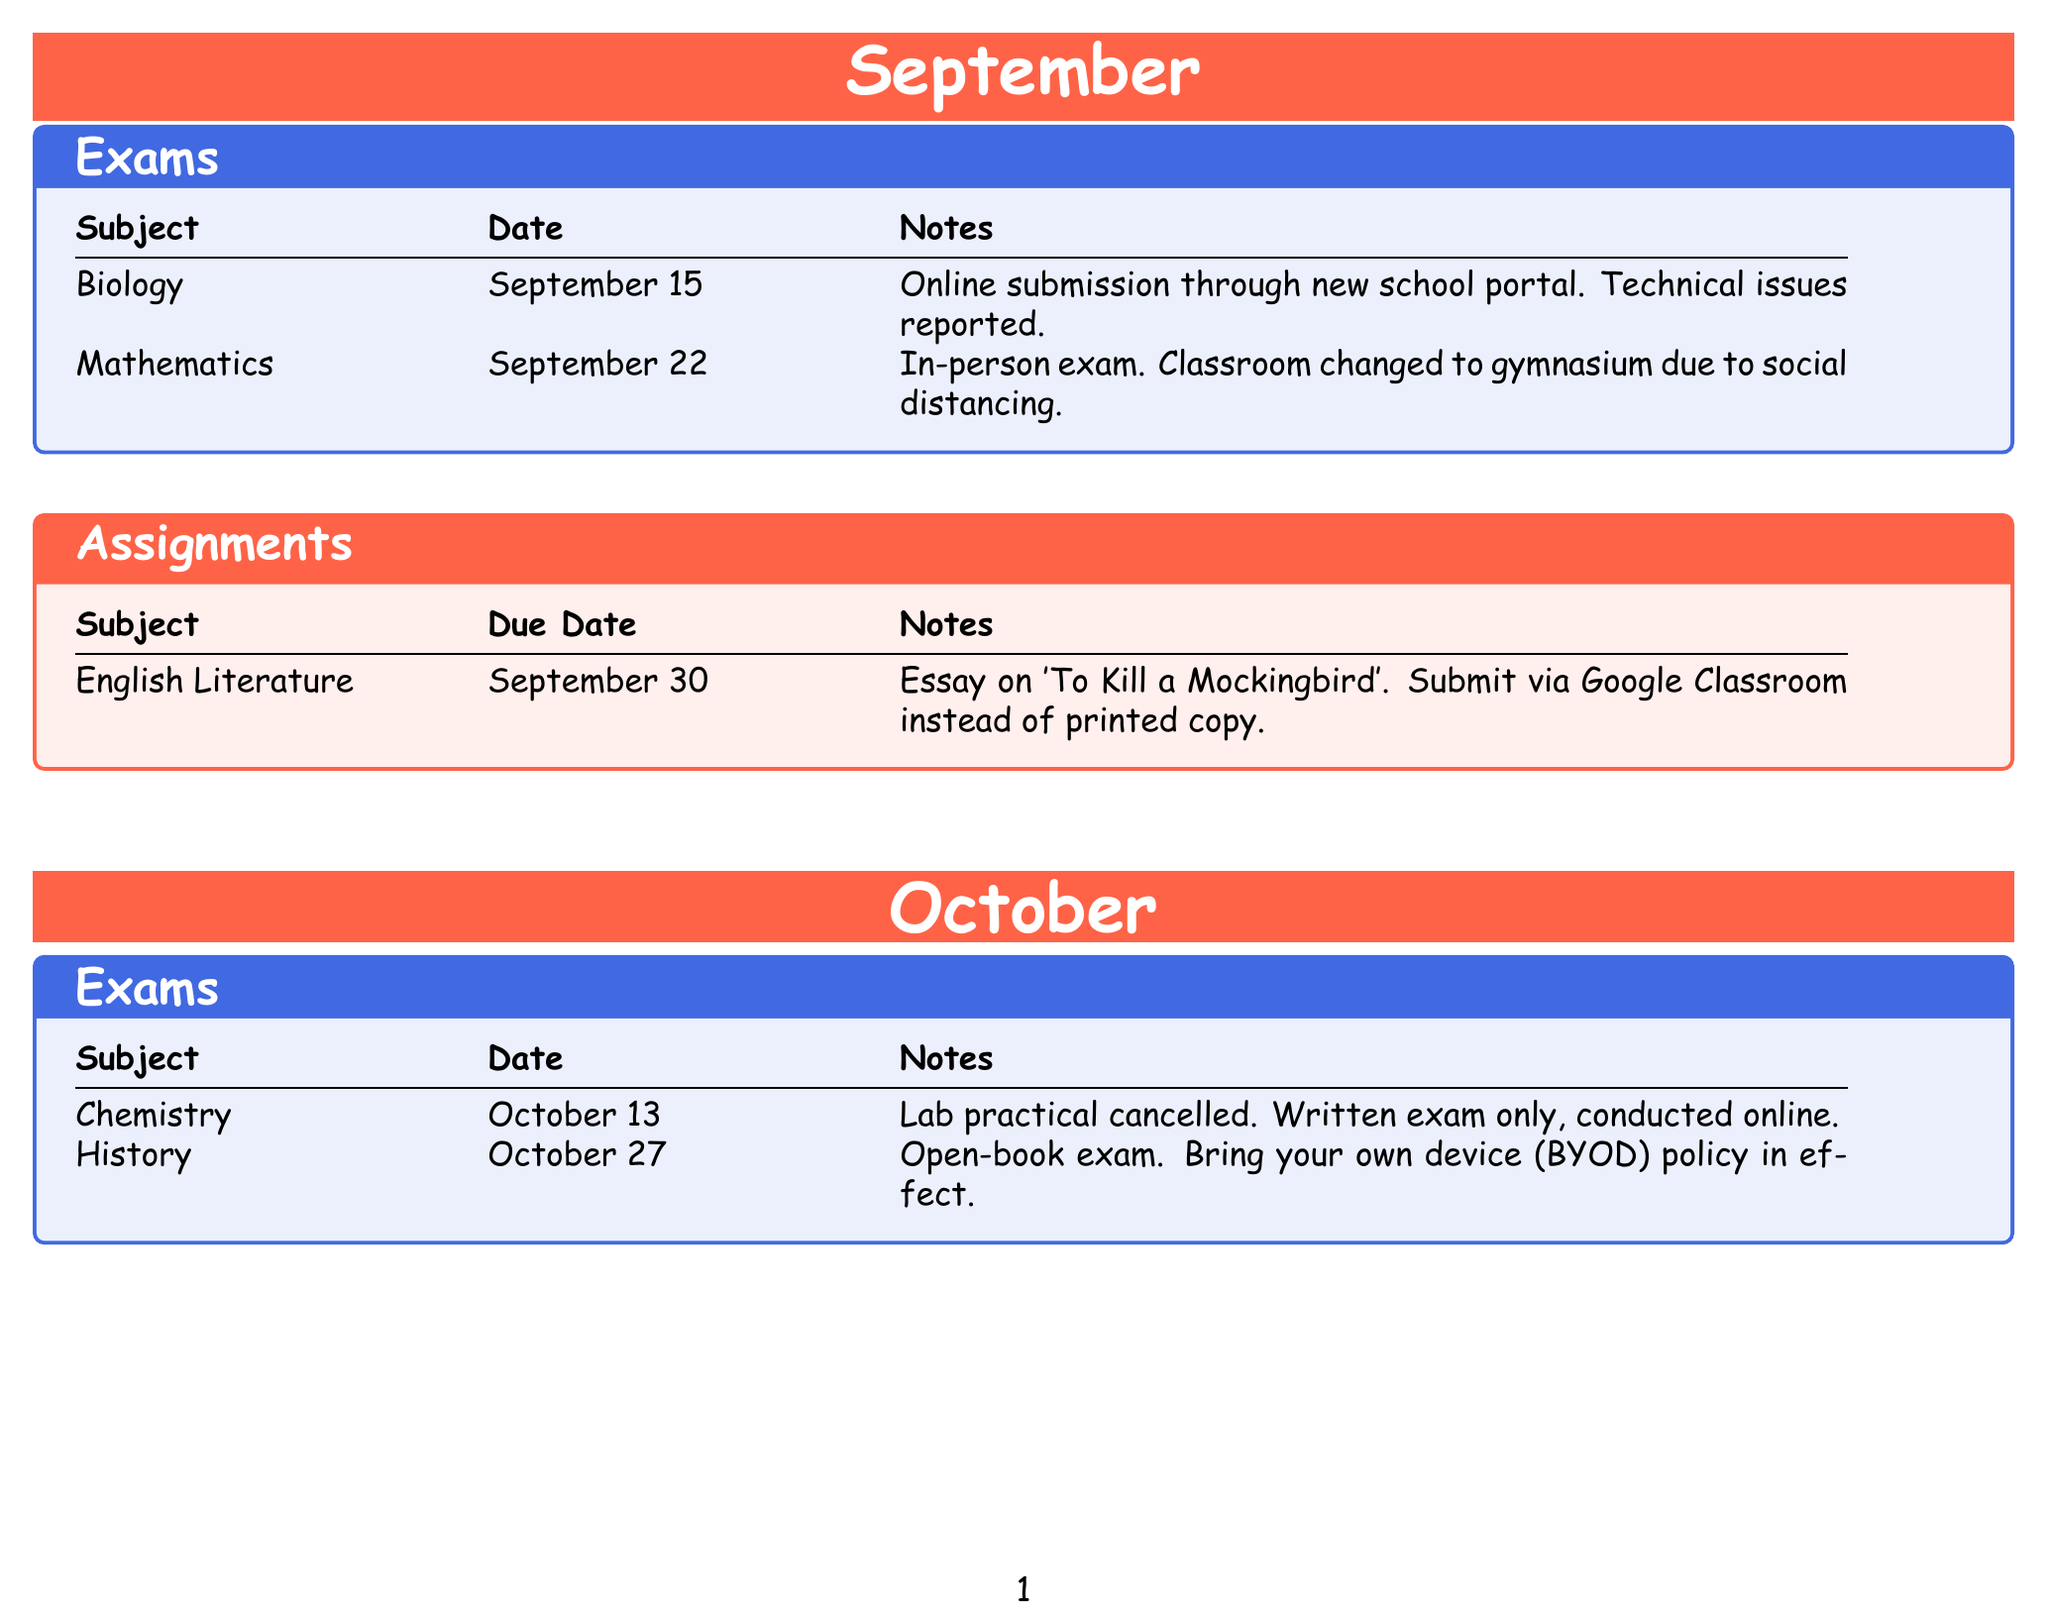What is the date of the Biology exam? The Biology exam is scheduled for September 15, as stated in the document.
Answer: September 15 What is the assignment due date for English Literature? The document specifies that the due date for the English Literature assignment is September 30.
Answer: September 30 Which subject has a hybrid exam in November? The document indicates that Physics has a hybrid exam that is part online and part in-person.
Answer: Physics How will the Chemistry exam be conducted? According to the notes, the Chemistry exam will be written only and conducted online due to the cancellation of the lab practical.
Answer: Online What is required for the History exam on October 27? The notes specify that students must bring their own device (BYOD) for the open-book History exam.
Answer: Bring your own device When is the due date for the Geography project presentation? The document details that the due date for the Geography group project presentation is November 15.
Answer: November 15 What platform should students use to submit the Computer Science assignment? The document states that the Computer Science programming project should be submitted via GitHub repository.
Answer: GitHub What are the submission requirements for the Art assignment? The notes indicate that a digital portfolio replaces physical artwork submission and should be showcased on Behance.
Answer: Behance 